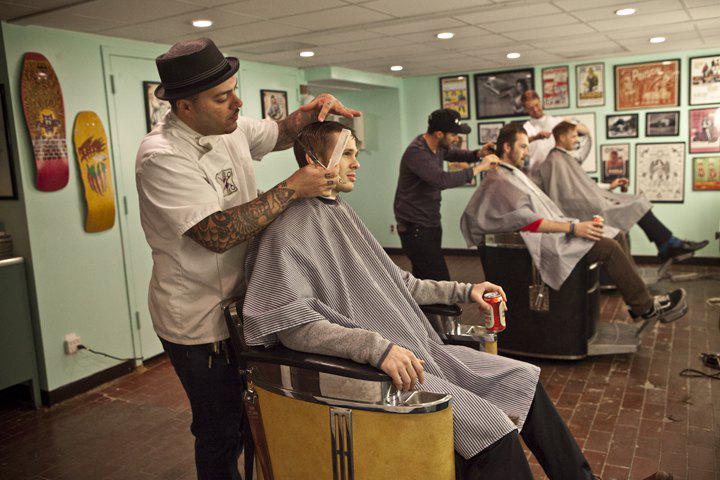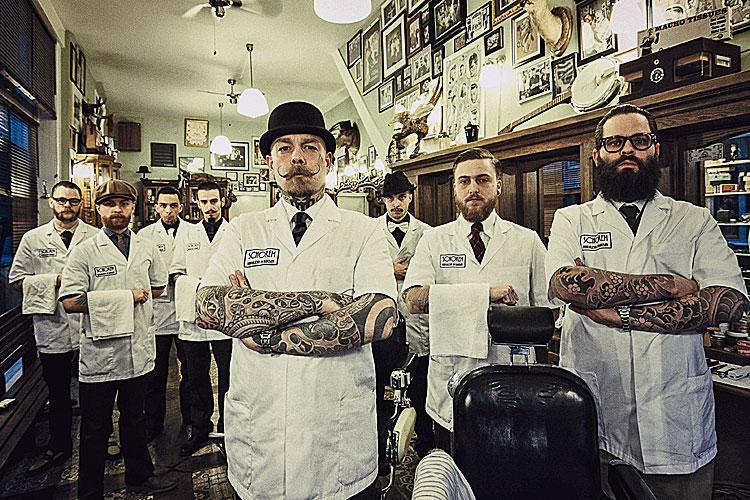The first image is the image on the left, the second image is the image on the right. For the images displayed, is the sentence "One image clearly shows one barber posed with one barber chair." factually correct? Answer yes or no. No. 